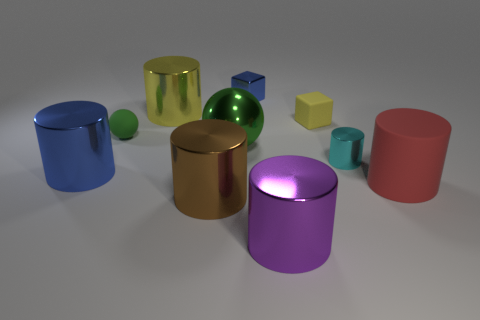Subtract all brown cylinders. How many cylinders are left? 5 Subtract all spheres. How many objects are left? 8 Subtract all blue cylinders. How many cylinders are left? 5 Add 6 small matte things. How many small matte things are left? 8 Add 7 tiny green matte objects. How many tiny green matte objects exist? 8 Subtract 2 green spheres. How many objects are left? 8 Subtract 4 cylinders. How many cylinders are left? 2 Subtract all gray blocks. Subtract all purple cylinders. How many blocks are left? 2 Subtract all red cylinders. How many green blocks are left? 0 Subtract all big rubber cylinders. Subtract all purple cubes. How many objects are left? 9 